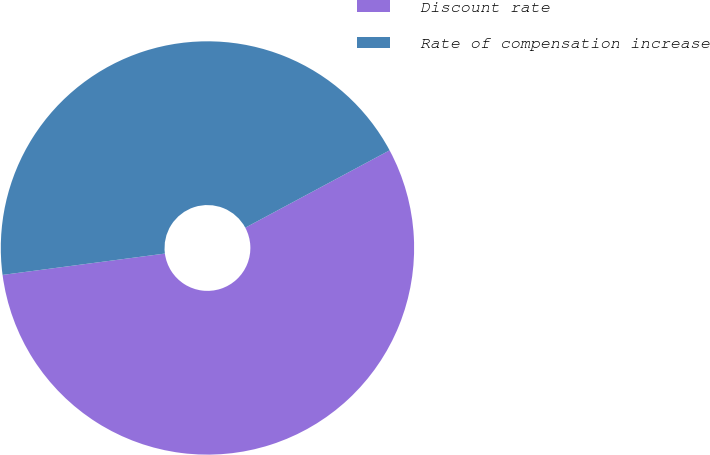Convert chart. <chart><loc_0><loc_0><loc_500><loc_500><pie_chart><fcel>Discount rate<fcel>Rate of compensation increase<nl><fcel>55.75%<fcel>44.25%<nl></chart> 